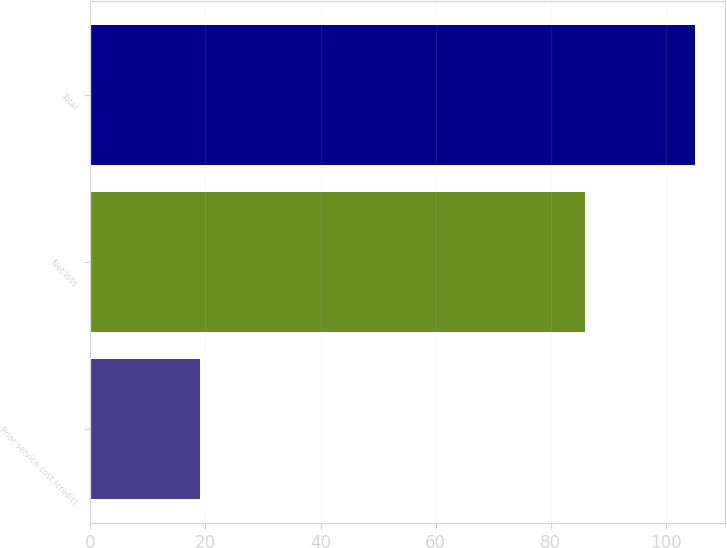<chart> <loc_0><loc_0><loc_500><loc_500><bar_chart><fcel>Prior service cost (credit)<fcel>Net loss<fcel>Total<nl><fcel>19<fcel>86<fcel>105<nl></chart> 